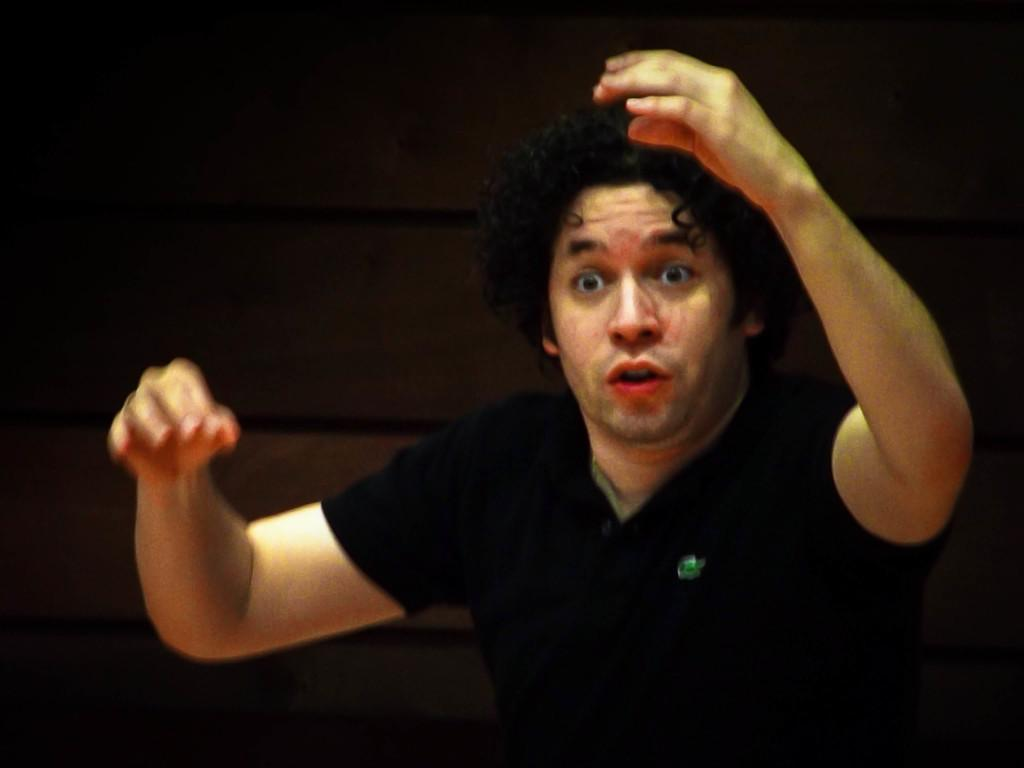What is the main subject of the picture? The main subject of the picture is a man. What is the man doing in the picture? The man is standing in the picture. What is the man wearing in the picture? The man is wearing a black shirt in the picture. What can be seen in the background of the picture? There is a black wall in the background of the picture. What type of tray is the secretary holding in the image? There is no secretary or tray present in the image; it features a man standing in front of a black wall. Can you see any squirrels in the image? There are no squirrels present in the image. 